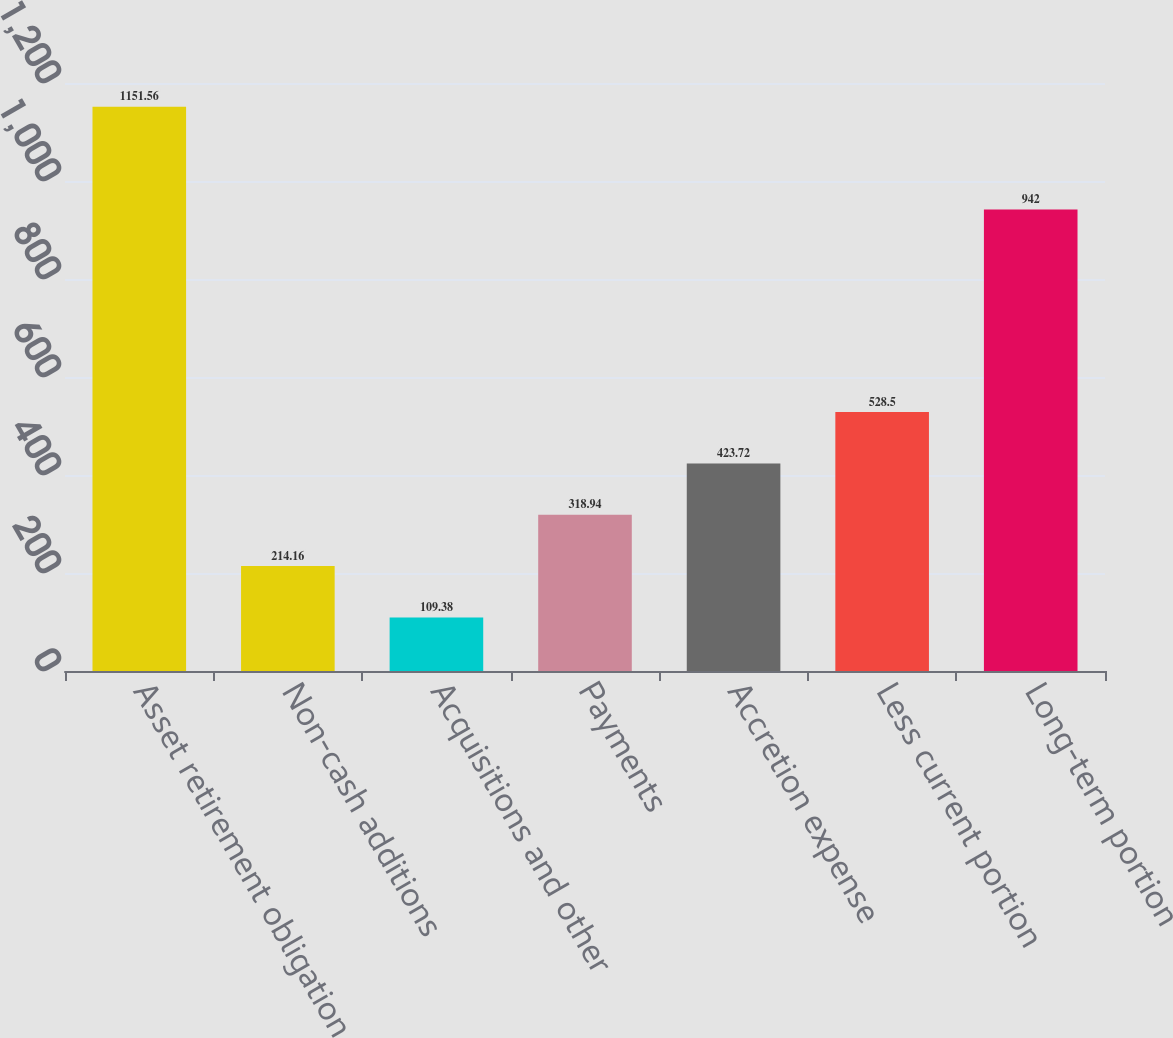<chart> <loc_0><loc_0><loc_500><loc_500><bar_chart><fcel>Asset retirement obligation<fcel>Non-cash additions<fcel>Acquisitions and other<fcel>Payments<fcel>Accretion expense<fcel>Less current portion<fcel>Long-term portion<nl><fcel>1151.56<fcel>214.16<fcel>109.38<fcel>318.94<fcel>423.72<fcel>528.5<fcel>942<nl></chart> 